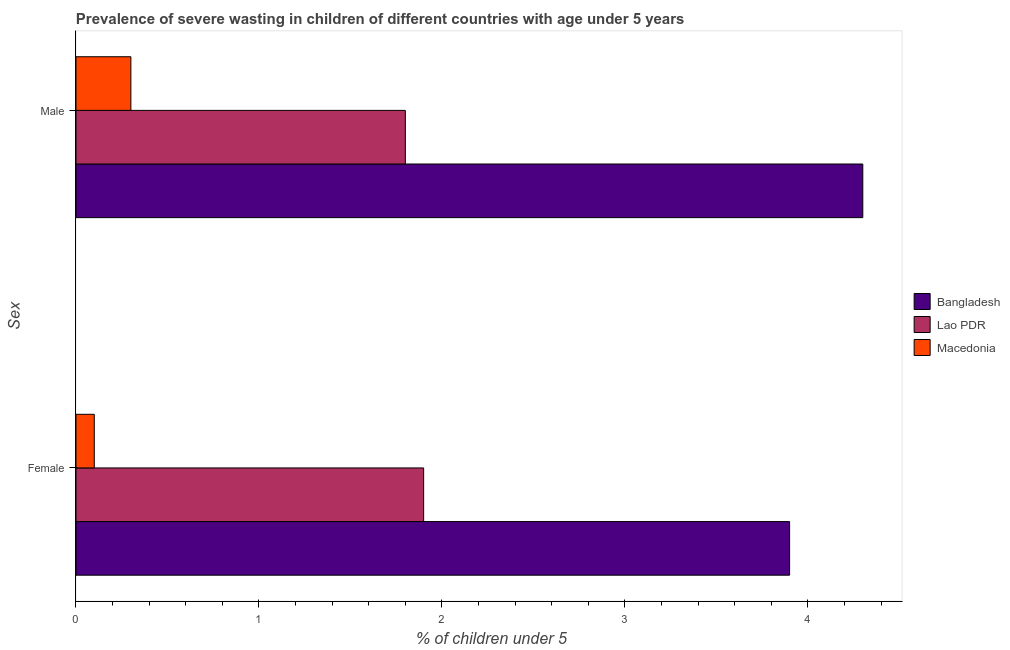How many different coloured bars are there?
Provide a short and direct response. 3. Are the number of bars per tick equal to the number of legend labels?
Make the answer very short. Yes. Are the number of bars on each tick of the Y-axis equal?
Your answer should be very brief. Yes. How many bars are there on the 1st tick from the bottom?
Your answer should be very brief. 3. What is the percentage of undernourished male children in Bangladesh?
Offer a terse response. 4.3. Across all countries, what is the maximum percentage of undernourished male children?
Provide a succinct answer. 4.3. Across all countries, what is the minimum percentage of undernourished male children?
Make the answer very short. 0.3. In which country was the percentage of undernourished male children maximum?
Ensure brevity in your answer.  Bangladesh. In which country was the percentage of undernourished female children minimum?
Your answer should be compact. Macedonia. What is the total percentage of undernourished male children in the graph?
Keep it short and to the point. 6.4. What is the difference between the percentage of undernourished female children in Macedonia and that in Lao PDR?
Your response must be concise. -1.8. What is the difference between the percentage of undernourished female children in Lao PDR and the percentage of undernourished male children in Macedonia?
Your response must be concise. 1.6. What is the average percentage of undernourished male children per country?
Provide a short and direct response. 2.13. What is the difference between the percentage of undernourished male children and percentage of undernourished female children in Macedonia?
Offer a terse response. 0.2. In how many countries, is the percentage of undernourished female children greater than 0.6000000000000001 %?
Your response must be concise. 2. What is the ratio of the percentage of undernourished female children in Bangladesh to that in Lao PDR?
Provide a succinct answer. 2.05. Is the percentage of undernourished female children in Bangladesh less than that in Macedonia?
Provide a short and direct response. No. In how many countries, is the percentage of undernourished female children greater than the average percentage of undernourished female children taken over all countries?
Your response must be concise. 1. What does the 2nd bar from the top in Male represents?
Provide a succinct answer. Lao PDR. What does the 3rd bar from the bottom in Female represents?
Offer a terse response. Macedonia. How many bars are there?
Provide a short and direct response. 6. Are all the bars in the graph horizontal?
Offer a terse response. Yes. How many countries are there in the graph?
Offer a very short reply. 3. What is the difference between two consecutive major ticks on the X-axis?
Your answer should be compact. 1. Does the graph contain any zero values?
Offer a terse response. No. Does the graph contain grids?
Keep it short and to the point. No. Where does the legend appear in the graph?
Ensure brevity in your answer.  Center right. How many legend labels are there?
Provide a succinct answer. 3. How are the legend labels stacked?
Offer a very short reply. Vertical. What is the title of the graph?
Make the answer very short. Prevalence of severe wasting in children of different countries with age under 5 years. What is the label or title of the X-axis?
Offer a terse response.  % of children under 5. What is the label or title of the Y-axis?
Your answer should be compact. Sex. What is the  % of children under 5 of Bangladesh in Female?
Make the answer very short. 3.9. What is the  % of children under 5 in Lao PDR in Female?
Offer a very short reply. 1.9. What is the  % of children under 5 in Macedonia in Female?
Provide a short and direct response. 0.1. What is the  % of children under 5 of Bangladesh in Male?
Your answer should be compact. 4.3. What is the  % of children under 5 in Lao PDR in Male?
Your answer should be compact. 1.8. What is the  % of children under 5 in Macedonia in Male?
Make the answer very short. 0.3. Across all Sex, what is the maximum  % of children under 5 of Bangladesh?
Offer a terse response. 4.3. Across all Sex, what is the maximum  % of children under 5 in Lao PDR?
Provide a short and direct response. 1.9. Across all Sex, what is the maximum  % of children under 5 in Macedonia?
Give a very brief answer. 0.3. Across all Sex, what is the minimum  % of children under 5 of Bangladesh?
Ensure brevity in your answer.  3.9. Across all Sex, what is the minimum  % of children under 5 of Lao PDR?
Your answer should be compact. 1.8. Across all Sex, what is the minimum  % of children under 5 in Macedonia?
Your answer should be very brief. 0.1. What is the total  % of children under 5 in Lao PDR in the graph?
Your answer should be very brief. 3.7. What is the total  % of children under 5 in Macedonia in the graph?
Ensure brevity in your answer.  0.4. What is the difference between the  % of children under 5 in Lao PDR in Female and that in Male?
Provide a succinct answer. 0.1. What is the difference between the  % of children under 5 of Macedonia in Female and that in Male?
Make the answer very short. -0.2. What is the difference between the  % of children under 5 of Bangladesh in Female and the  % of children under 5 of Macedonia in Male?
Provide a short and direct response. 3.6. What is the difference between the  % of children under 5 in Lao PDR in Female and the  % of children under 5 in Macedonia in Male?
Your answer should be compact. 1.6. What is the average  % of children under 5 in Bangladesh per Sex?
Your answer should be very brief. 4.1. What is the average  % of children under 5 in Lao PDR per Sex?
Your answer should be very brief. 1.85. What is the average  % of children under 5 in Macedonia per Sex?
Ensure brevity in your answer.  0.2. What is the difference between the  % of children under 5 of Lao PDR and  % of children under 5 of Macedonia in Female?
Make the answer very short. 1.8. What is the difference between the  % of children under 5 of Bangladesh and  % of children under 5 of Lao PDR in Male?
Provide a succinct answer. 2.5. What is the ratio of the  % of children under 5 of Bangladesh in Female to that in Male?
Provide a succinct answer. 0.91. What is the ratio of the  % of children under 5 in Lao PDR in Female to that in Male?
Provide a short and direct response. 1.06. What is the ratio of the  % of children under 5 in Macedonia in Female to that in Male?
Make the answer very short. 0.33. What is the difference between the highest and the second highest  % of children under 5 of Macedonia?
Offer a very short reply. 0.2. 